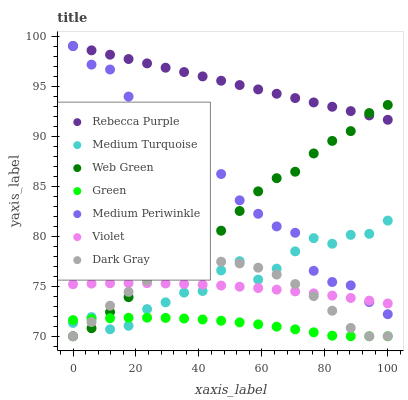Does Green have the minimum area under the curve?
Answer yes or no. Yes. Does Rebecca Purple have the maximum area under the curve?
Answer yes or no. Yes. Does Web Green have the minimum area under the curve?
Answer yes or no. No. Does Web Green have the maximum area under the curve?
Answer yes or no. No. Is Rebecca Purple the smoothest?
Answer yes or no. Yes. Is Medium Periwinkle the roughest?
Answer yes or no. Yes. Is Web Green the smoothest?
Answer yes or no. No. Is Web Green the roughest?
Answer yes or no. No. Does Web Green have the lowest value?
Answer yes or no. Yes. Does Rebecca Purple have the lowest value?
Answer yes or no. No. Does Rebecca Purple have the highest value?
Answer yes or no. Yes. Does Web Green have the highest value?
Answer yes or no. No. Is Medium Turquoise less than Rebecca Purple?
Answer yes or no. Yes. Is Medium Periwinkle greater than Green?
Answer yes or no. Yes. Does Violet intersect Dark Gray?
Answer yes or no. Yes. Is Violet less than Dark Gray?
Answer yes or no. No. Is Violet greater than Dark Gray?
Answer yes or no. No. Does Medium Turquoise intersect Rebecca Purple?
Answer yes or no. No. 